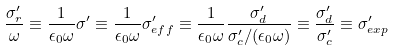Convert formula to latex. <formula><loc_0><loc_0><loc_500><loc_500>\frac { \sigma ^ { \prime } _ { r } } { \omega } \equiv \frac { 1 } { \epsilon _ { 0 } \omega } \sigma ^ { \prime } \equiv \frac { 1 } { \epsilon _ { 0 } \omega } \sigma ^ { \prime } _ { e f f } \equiv \frac { 1 } { \epsilon _ { 0 } \omega } \frac { \sigma _ { d } ^ { \prime } } { \sigma _ { c } ^ { \prime } / ( \epsilon _ { 0 } \omega ) } \equiv \frac { \sigma _ { d } ^ { \prime } } { \sigma _ { c } ^ { \prime } } \equiv \sigma ^ { \prime } _ { e x p }</formula> 